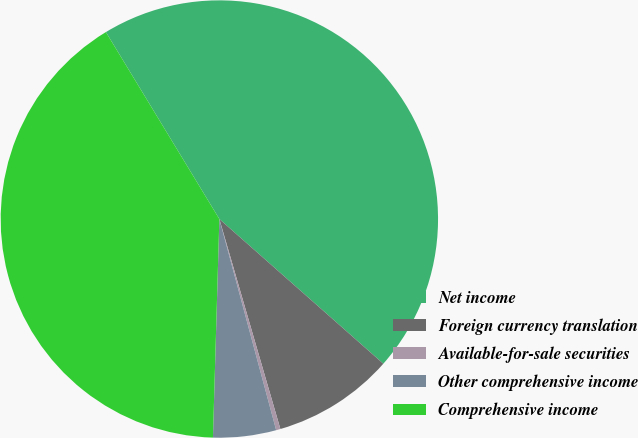Convert chart. <chart><loc_0><loc_0><loc_500><loc_500><pie_chart><fcel>Net income<fcel>Foreign currency translation<fcel>Available-for-sale securities<fcel>Other comprehensive income<fcel>Comprehensive income<nl><fcel>45.19%<fcel>8.99%<fcel>0.32%<fcel>4.65%<fcel>40.85%<nl></chart> 